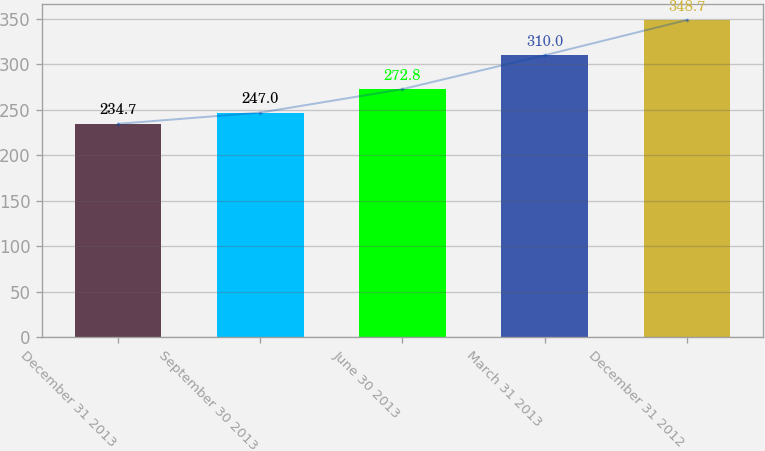<chart> <loc_0><loc_0><loc_500><loc_500><bar_chart><fcel>December 31 2013<fcel>September 30 2013<fcel>June 30 2013<fcel>March 31 2013<fcel>December 31 2012<nl><fcel>234.7<fcel>247<fcel>272.8<fcel>310<fcel>348.7<nl></chart> 